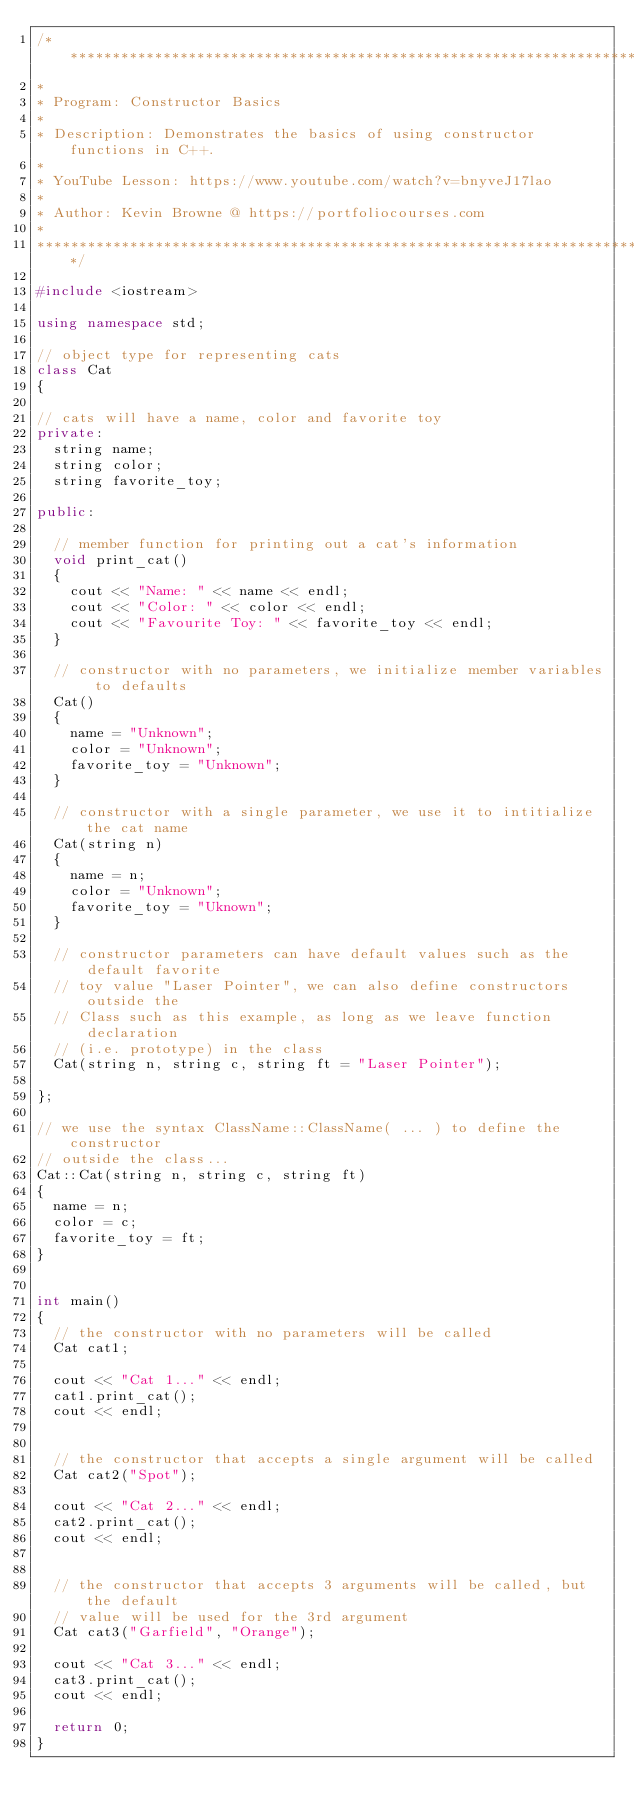Convert code to text. <code><loc_0><loc_0><loc_500><loc_500><_C++_>/*******************************************************************************
*
* Program: Constructor Basics
* 
* Description: Demonstrates the basics of using constructor functions in C++.
*
* YouTube Lesson: https://www.youtube.com/watch?v=bnyveJ17lao 
*
* Author: Kevin Browne @ https://portfoliocourses.com
*
*******************************************************************************/

#include <iostream>

using namespace std;

// object type for representing cats
class Cat
{

// cats will have a name, color and favorite toy
private:
  string name;
  string color;
  string favorite_toy;
  
public:
  
  // member function for printing out a cat's information
  void print_cat()
  {
    cout << "Name: " << name << endl;
    cout << "Color: " << color << endl;
    cout << "Favourite Toy: " << favorite_toy << endl;
  }
  
  // constructor with no parameters, we initialize member variables to defaults
  Cat()
  {
    name = "Unknown";
    color = "Unknown";
    favorite_toy = "Unknown";
  }
  
  // constructor with a single parameter, we use it to intitialize the cat name
  Cat(string n)
  {
    name = n;
    color = "Unknown";
    favorite_toy = "Uknown";
  }
  
  // constructor parameters can have default values such as the default favorite 
  // toy value "Laser Pointer", we can also define constructors outside the 
  // Class such as this example, as long as we leave function declaration 
  // (i.e. prototype) in the class
  Cat(string n, string c, string ft = "Laser Pointer");
  
};

// we use the syntax ClassName::ClassName( ... ) to define the constructor 
// outside the class...
Cat::Cat(string n, string c, string ft)
{
  name = n;
  color = c;
  favorite_toy = ft;
}


int main()
{
  // the constructor with no parameters will be called
  Cat cat1;
  
  cout << "Cat 1..." << endl;
  cat1.print_cat();
  cout << endl;
  
  
  // the constructor that accepts a single argument will be called
  Cat cat2("Spot");
  
  cout << "Cat 2..." << endl;
  cat2.print_cat();
  cout << endl;
  

  // the constructor that accepts 3 arguments will be called, but the default 
  // value will be used for the 3rd argument
  Cat cat3("Garfield", "Orange");
  
  cout << "Cat 3..." << endl;
  cat3.print_cat();
  cout << endl;
  
  return 0;
}</code> 